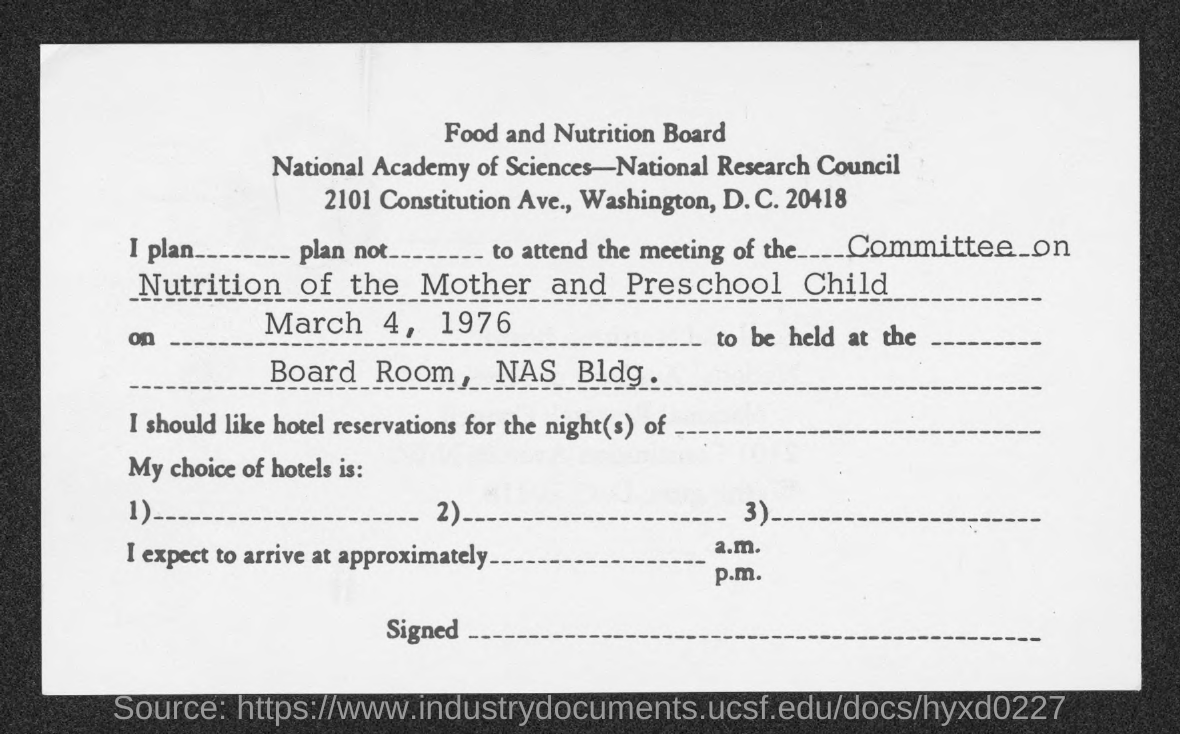What is the name of the board mentioned in the given form ?
Keep it short and to the point. Food and nutrition board. What is the date of meeting ?
Keep it short and to the point. March 4, 1976. 